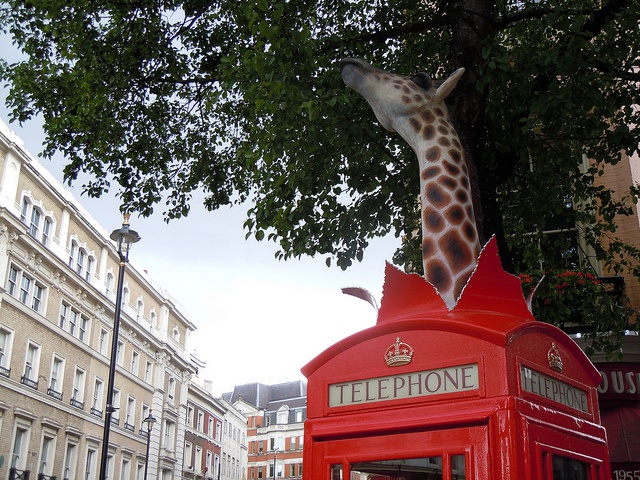Describe the objects in this image and their specific colors. I can see a giraffe in teal, gray, black, maroon, and darkgray tones in this image. 